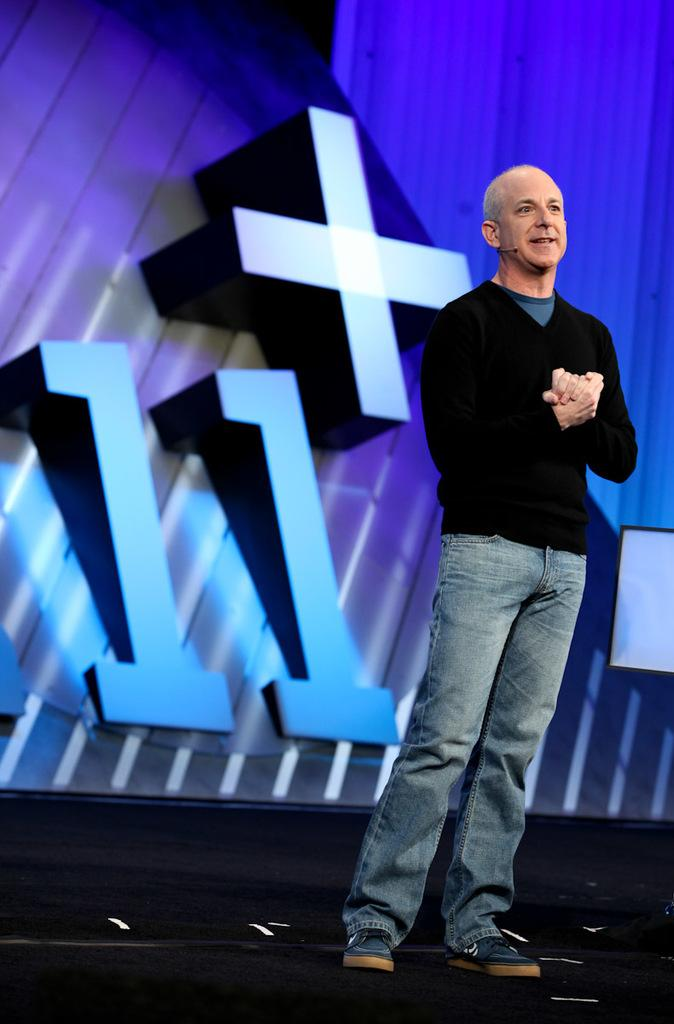What is the main subject of the image? There is a man standing in the image. Where is the man positioned in the image? The man is standing on the floor. What is located behind the man in the image? There is a screen behind the man. What can be seen on the screen? Numbers are displayed on the screen. What type of honey is the man using to write on the quill in the image? There is no honey or quill present in the image; the man is standing near a screen displaying numbers. 